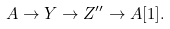<formula> <loc_0><loc_0><loc_500><loc_500>A \to Y \to Z ^ { \prime \prime } \to A [ 1 ] .</formula> 